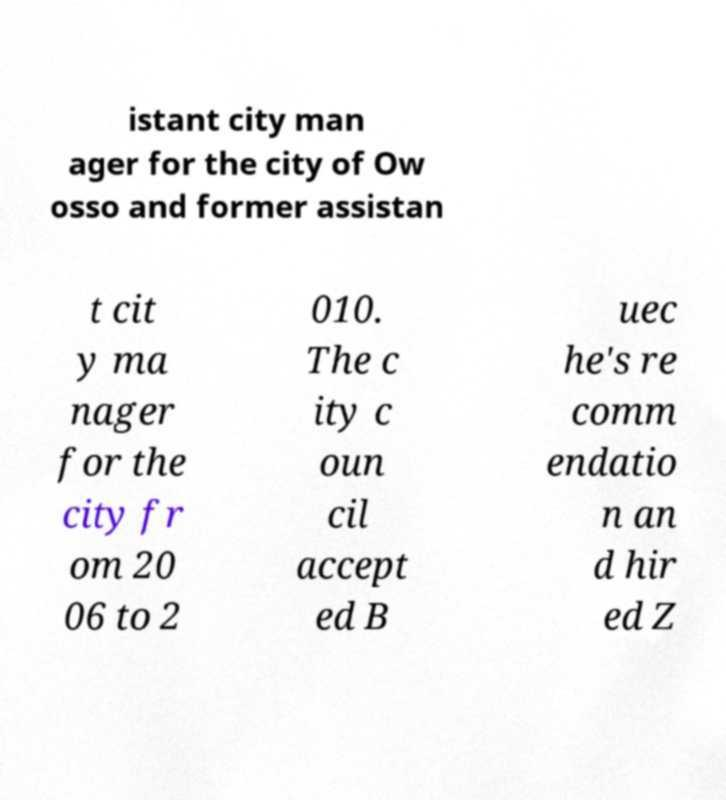Could you extract and type out the text from this image? istant city man ager for the city of Ow osso and former assistan t cit y ma nager for the city fr om 20 06 to 2 010. The c ity c oun cil accept ed B uec he's re comm endatio n an d hir ed Z 